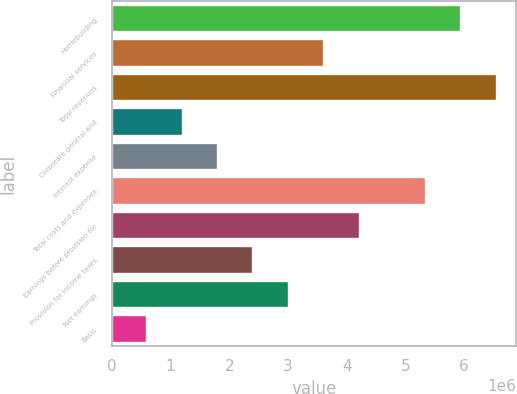Convert chart. <chart><loc_0><loc_0><loc_500><loc_500><bar_chart><fcel>Homebuilding<fcel>Financial services<fcel>Total revenues<fcel>Corporate general and<fcel>Interest expense<fcel>Total costs and expenses<fcel>Earnings before provision for<fcel>Provision for income taxes<fcel>Net earnings<fcel>Basic<nl><fcel>5.95281e+06<fcel>3.61758e+06<fcel>6.55574e+06<fcel>1.20587e+06<fcel>1.80879e+06<fcel>5.34988e+06<fcel>4.22051e+06<fcel>2.41172e+06<fcel>3.01465e+06<fcel>602936<nl></chart> 